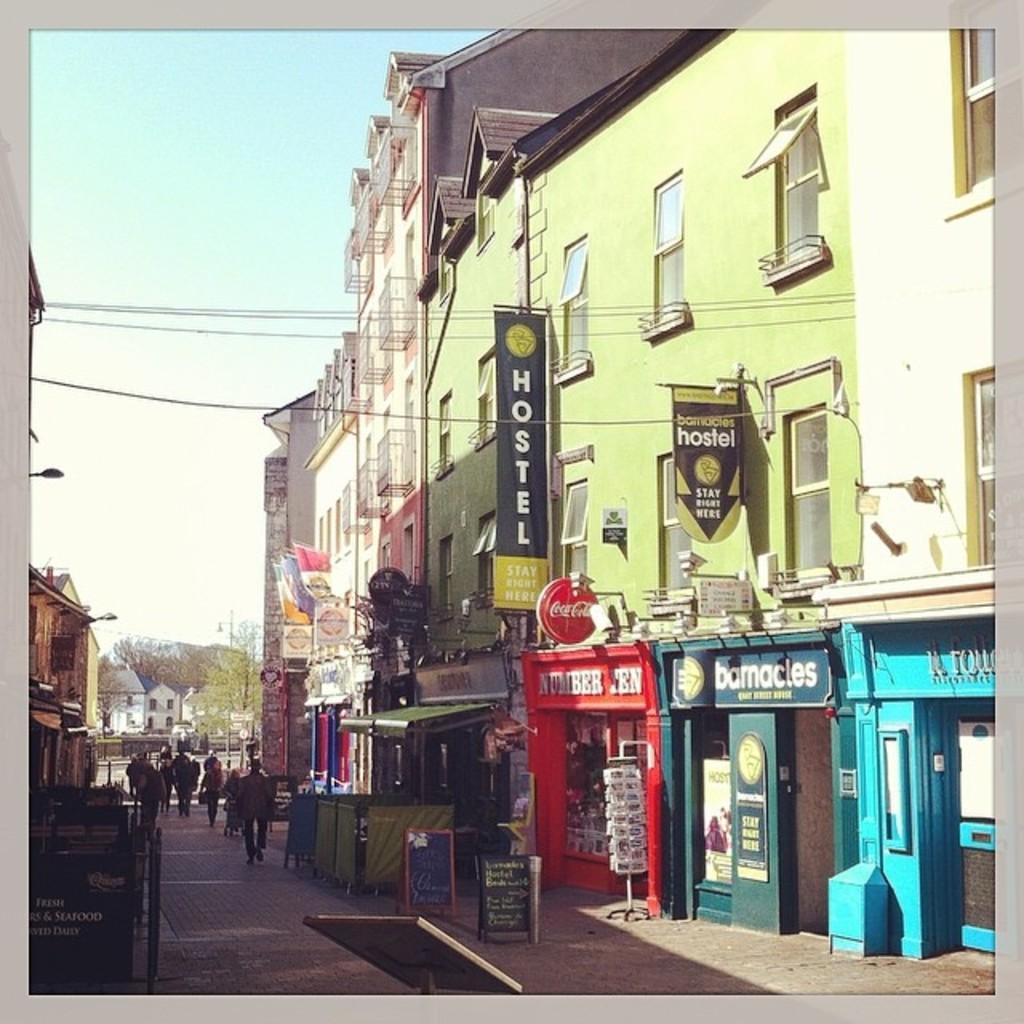Describe this image in one or two sentences. In the center of the image we can see the sky, buildings, trees, banners, windows, boards with some text, wires, few people are walking and a few other objects. 